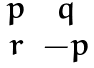<formula> <loc_0><loc_0><loc_500><loc_500>\begin{matrix} p & q \\ r & - p \end{matrix}</formula> 